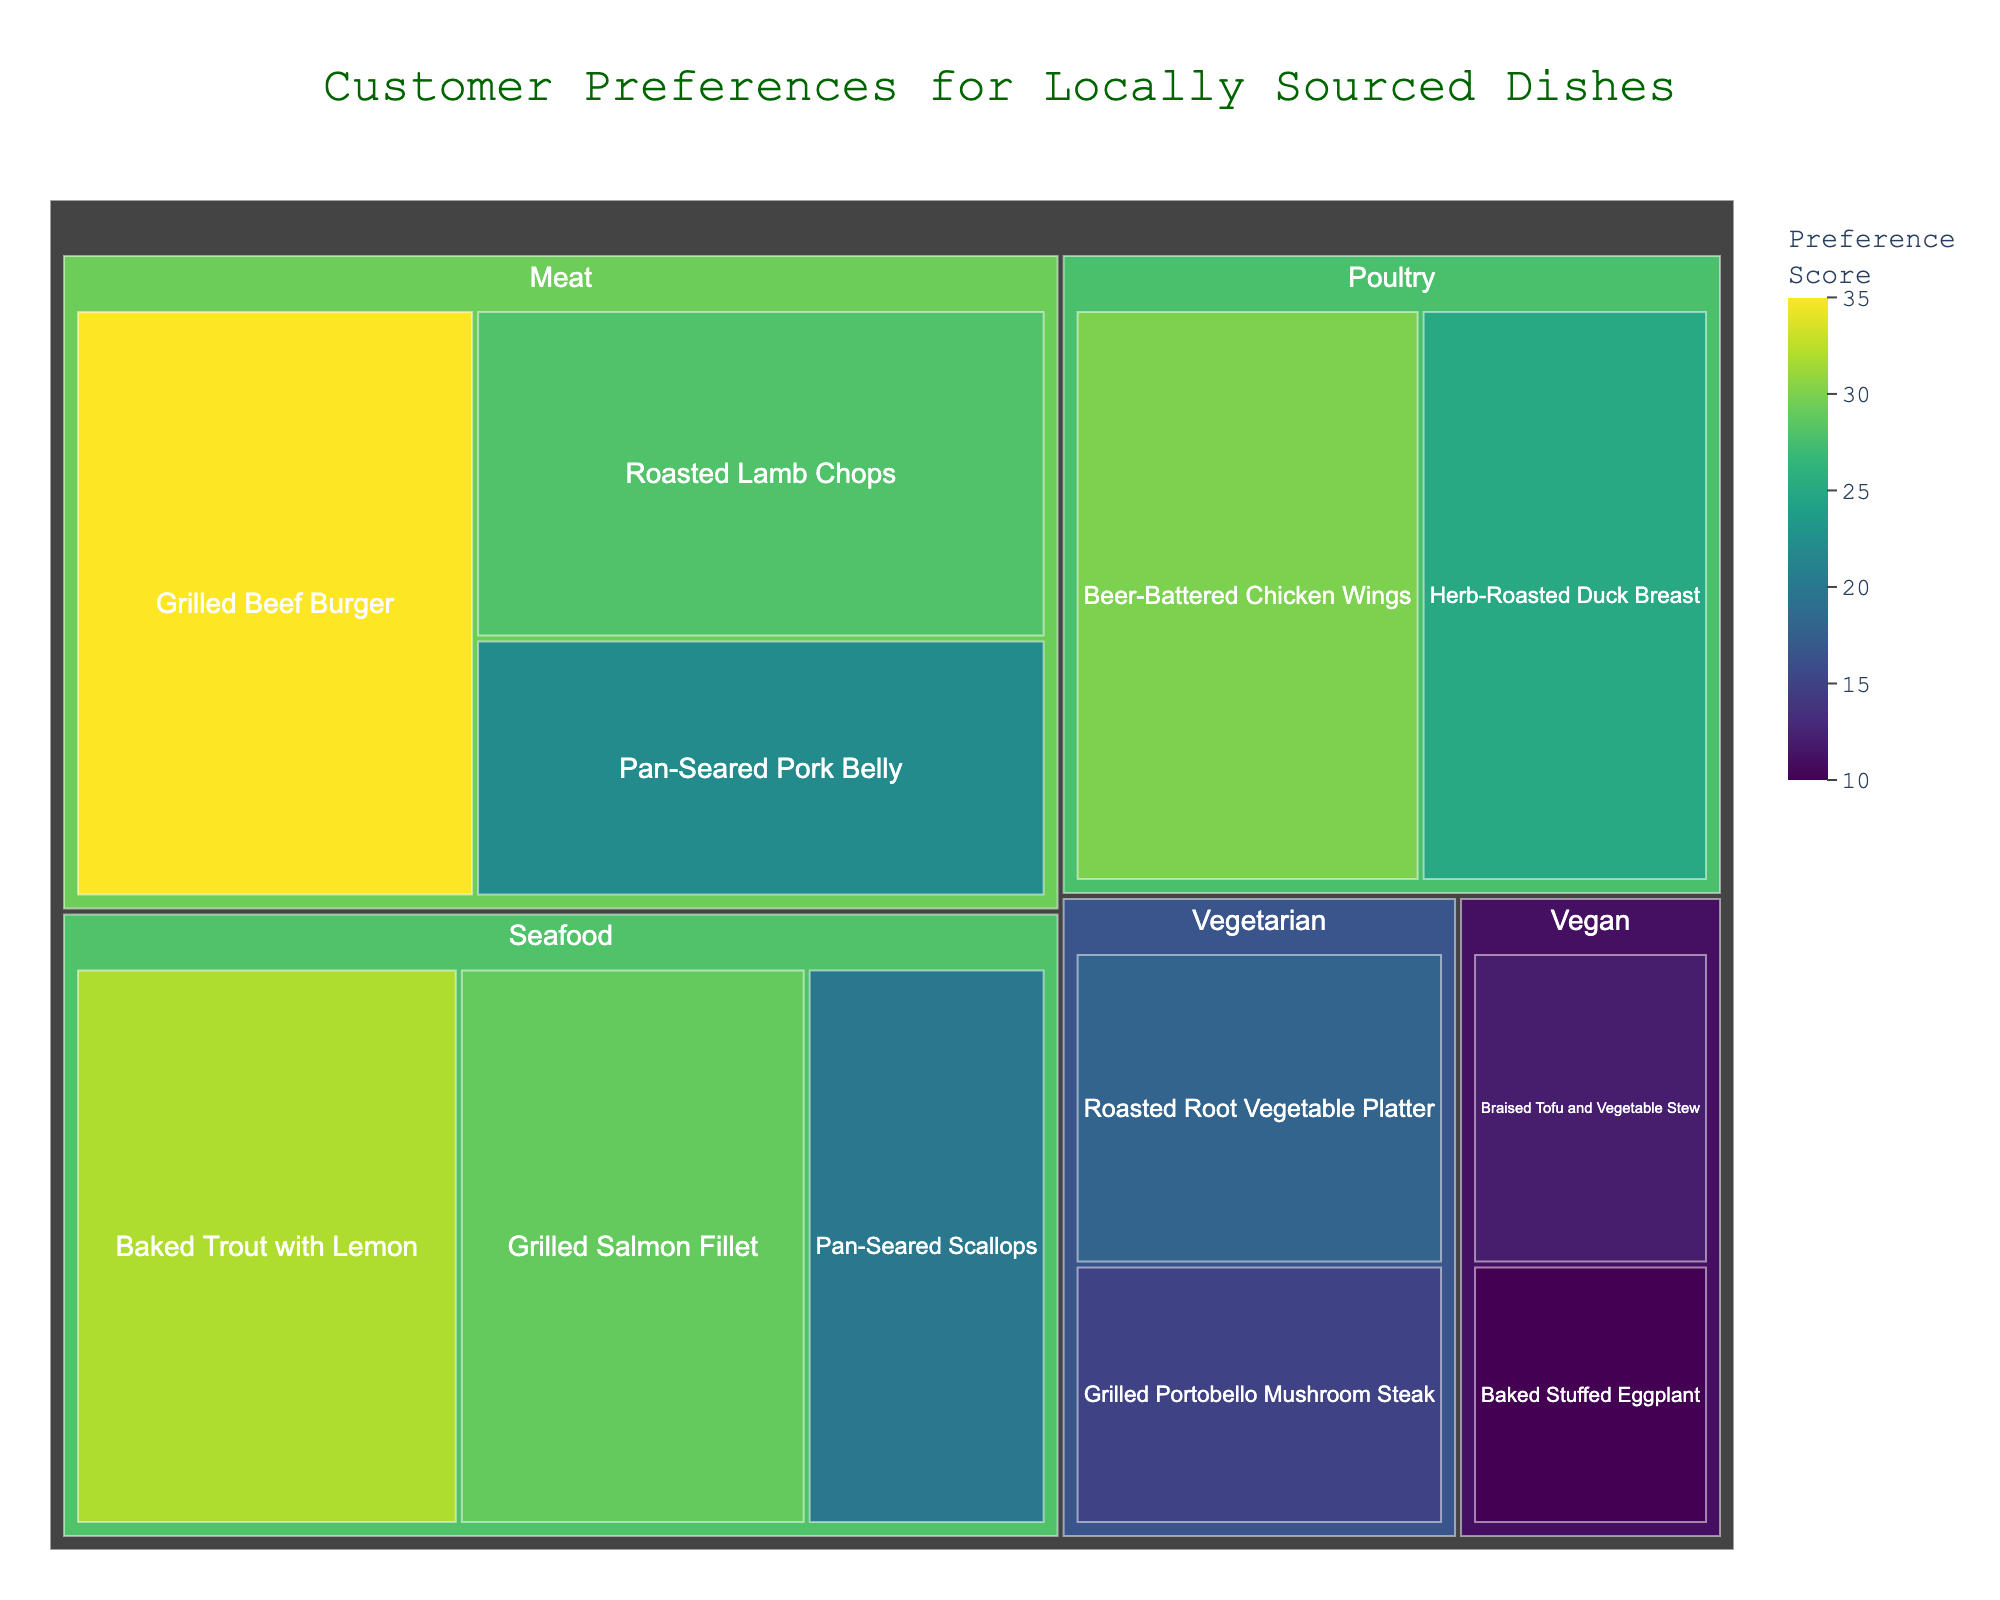How many subcategories are in the 'Seafood' category? There are three subcategories under the 'Seafood' category: Baked Trout with Lemon, Grilled Salmon Fillet, and Pan-Seared Scallops.
Answer: 3 Which dish has the highest customer preference score? The Grilled Beef Burger in the 'Meat' category has the highest preference score, with a value of 35.
Answer: Grilled Beef Burger Which category has the lowest total preference score: Vegetarian or Vegan? Summing the values for each subcategory: Vegetarian has (18 + 15) = 33, and Vegan has (12 + 10) = 22. Therefore, Vegan has the lowest total preference score.
Answer: Vegan What is the sum of preference scores for 'Pan-Seared' dishes? Adding the values for Pan-Seared Pork Belly (22) and Pan-Seared Scallops (20) gives a total of 22 + 20 = 42.
Answer: 42 Which cooking method is more popular, roasted or grilled, for 'Meat' category? Summing the values: Roasted Lamb Chops (28) = 28 and Grilled Beef Burger (35) = 35. Grilled is more popular than roasted for 'Meat'.
Answer: Grilled What is the average preference score for 'Vegetarian' dishes? Summing and averaging the values for 'Vegetarian' dishes: (18 + 15) / 2 = 33 / 2 = 16.5.
Answer: 16.5 Which has a higher individual preference score, Beer-Battered Chicken Wings or Grilled Salmon Fillet? Comparing the values: Beer-Battered Chicken Wings (30) and Grilled Salmon Fillet (29). The individual preference score for Beer-Battered Chicken Wings is higher.
Answer: Beer-Battered Chicken Wings Between 'Herb-Roasted Duck Breast' and 'Roasted Root Vegetable Platter', which has a lower preference score? The preference score for Herb-Roasted Duck Breast (25) is higher compared to Roasted Root Vegetable Platter (18).
Answer: Roasted Root Vegetable Platter What is the combined preference score of all 'Meat' dishes? Adding the values for all 'Meat' dishes: Grilled Beef Burger (35) + Roasted Lamb Chops (28) + Pan-Seared Pork Belly (22) = 35 + 28 + 22 = 85.
Answer: 85 